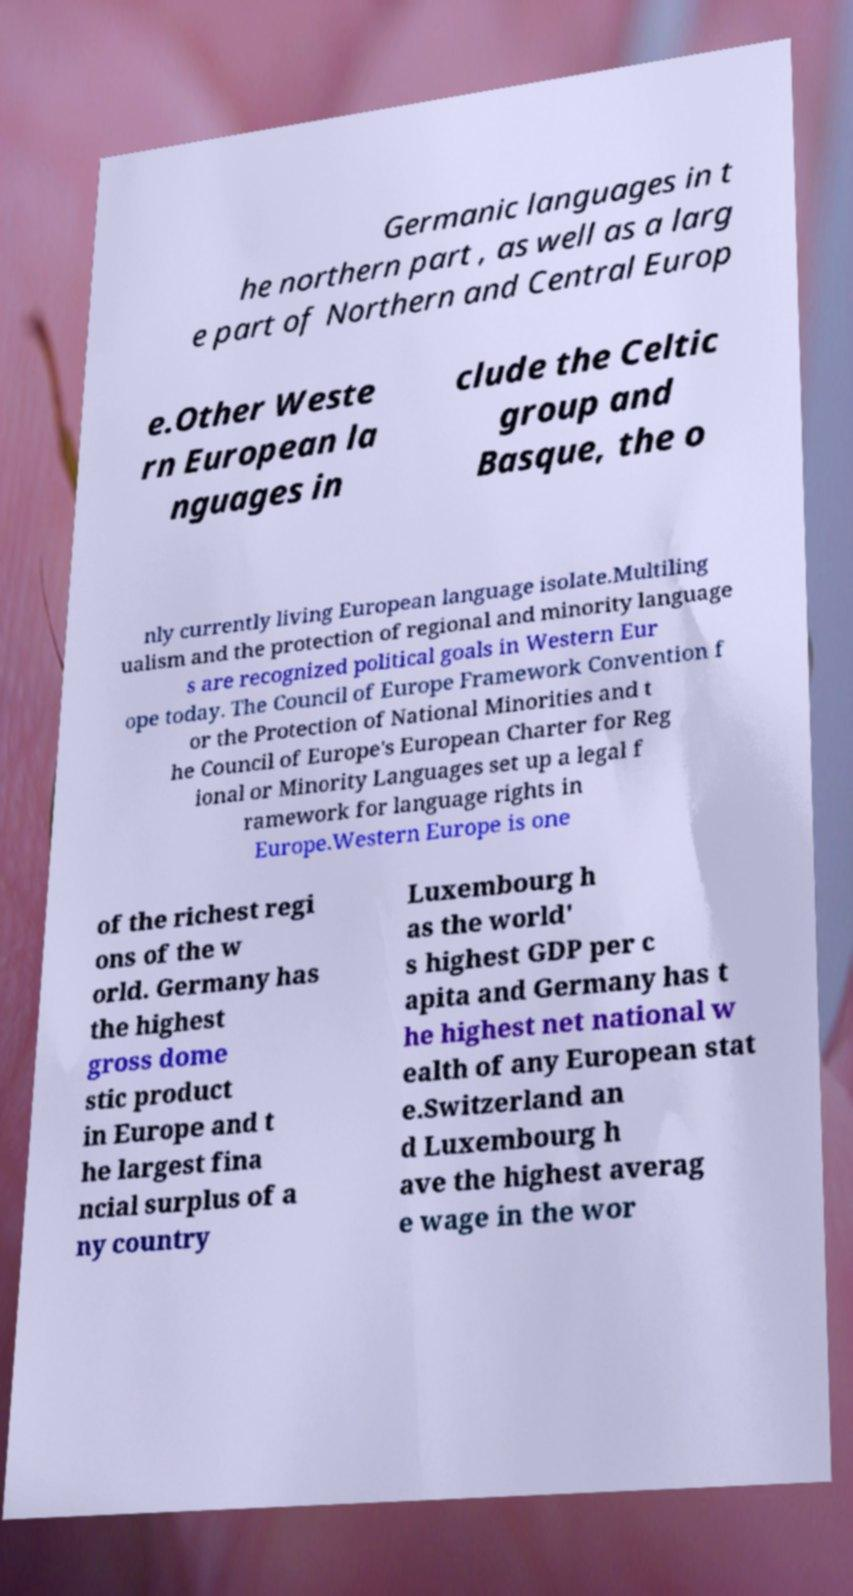Can you read and provide the text displayed in the image?This photo seems to have some interesting text. Can you extract and type it out for me? Germanic languages in t he northern part , as well as a larg e part of Northern and Central Europ e.Other Weste rn European la nguages in clude the Celtic group and Basque, the o nly currently living European language isolate.Multiling ualism and the protection of regional and minority language s are recognized political goals in Western Eur ope today. The Council of Europe Framework Convention f or the Protection of National Minorities and t he Council of Europe's European Charter for Reg ional or Minority Languages set up a legal f ramework for language rights in Europe.Western Europe is one of the richest regi ons of the w orld. Germany has the highest gross dome stic product in Europe and t he largest fina ncial surplus of a ny country Luxembourg h as the world' s highest GDP per c apita and Germany has t he highest net national w ealth of any European stat e.Switzerland an d Luxembourg h ave the highest averag e wage in the wor 